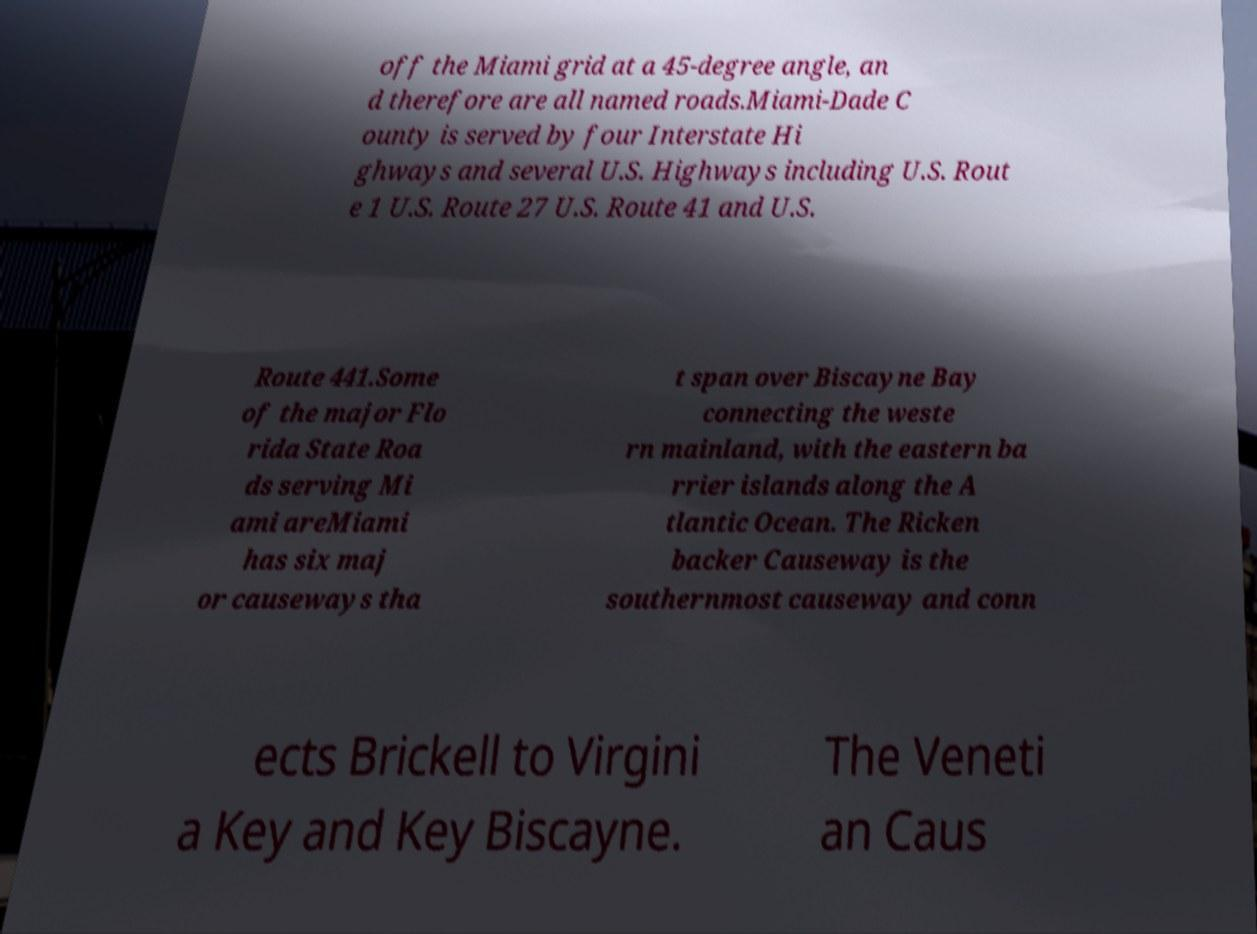Can you read and provide the text displayed in the image?This photo seems to have some interesting text. Can you extract and type it out for me? off the Miami grid at a 45-degree angle, an d therefore are all named roads.Miami-Dade C ounty is served by four Interstate Hi ghways and several U.S. Highways including U.S. Rout e 1 U.S. Route 27 U.S. Route 41 and U.S. Route 441.Some of the major Flo rida State Roa ds serving Mi ami areMiami has six maj or causeways tha t span over Biscayne Bay connecting the weste rn mainland, with the eastern ba rrier islands along the A tlantic Ocean. The Ricken backer Causeway is the southernmost causeway and conn ects Brickell to Virgini a Key and Key Biscayne. The Veneti an Caus 